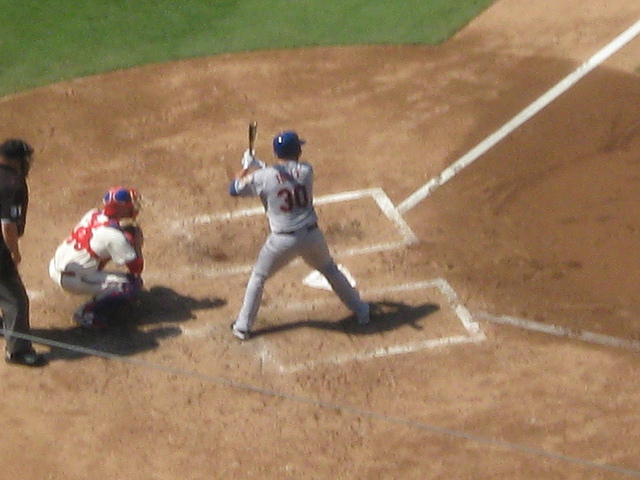Identify and read out the text in this image. 30 31 